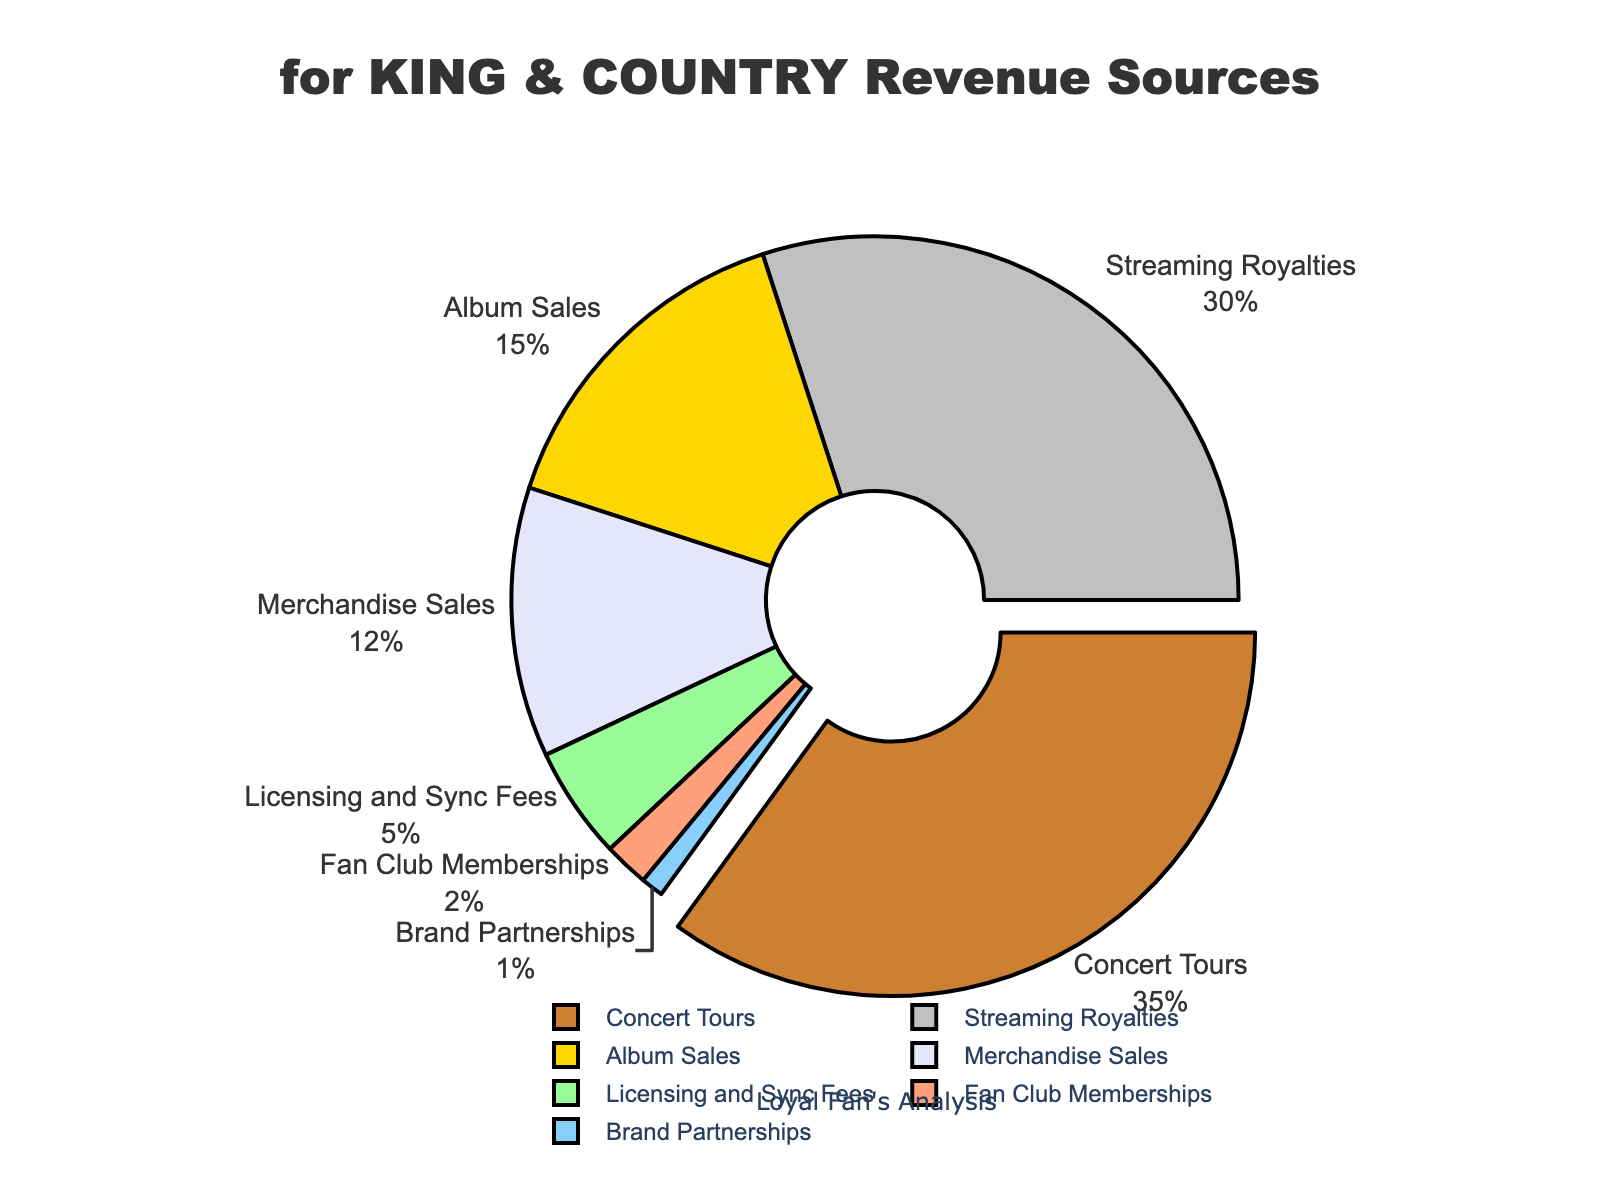What's the largest source of revenue for for KING & COUNTRY? The pie chart shows that Concert Tours have the highest percentage, which is 35%.
Answer: Concert Tours What's the combined percentage of revenue from Album Sales and Streaming Royalties? Album Sales account for 15% and Streaming Royalties for 30%. Adding these together, 15% + 30% = 45%.
Answer: 45% Which revenue source generates less income: Merchandise Sales or Licensing and Sync Fees? Merchandise Sales account for 12% while Licensing and Sync Fees account for 5%. Since 5% is less than 12%, Licensing and Sync Fees generate less income.
Answer: Licensing and Sync Fees What's the difference in revenue percentage between Concert Tours and Brand Partnerships? Concert Tours generate 35% and Brand Partnerships generate 1%. The difference is 35% - 1% = 34%.
Answer: 34% Which sources contribute less than 10% each to the revenue? From the chart, Licensing and Sync Fees contribute 5%, Fan Club Memberships contribute 2%, and Brand Partnerships contribute 1%.
Answer: Licensing and Sync Fees, Fan Club Memberships, Brand Partnerships If you combine Merchandise Sales and Fan Club Memberships, do they contribute more or less than Streaming Royalties alone? Merchandise Sales contribute 12% and Fan Club Memberships contribute 2%. Adding these together, 12% + 2% = 14%. Since Streaming Royalties contribute 30%, 14% is less than 30%.
Answer: Less What's the percentage contribution of the smallest revenue source? The smallest revenue source in the chart is Brand Partnerships, which contributes 1%.
Answer: 1% Which revenue source is pulled out from the pie chart and why? The data indicates that the Concert Tours segment is pulled out since it has the maximum percentage of 35%.
Answer: Concert Tours 